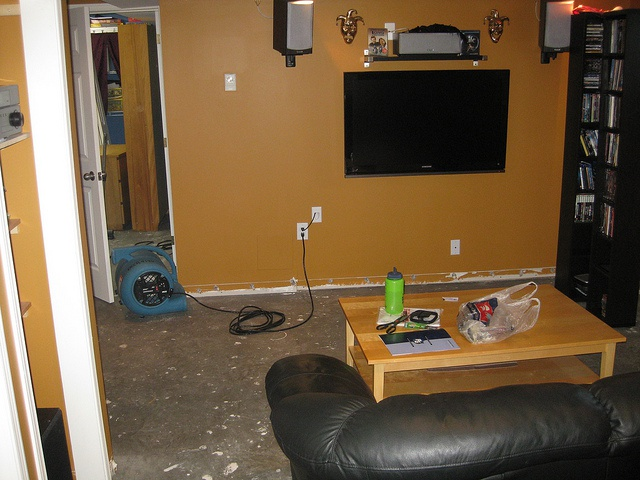Describe the objects in this image and their specific colors. I can see couch in olive, black, and gray tones, tv in olive, black, maroon, and brown tones, book in olive, black, gray, and darkgray tones, book in olive, darkgray, black, gray, and orange tones, and bottle in olive, lightgreen, and purple tones in this image. 